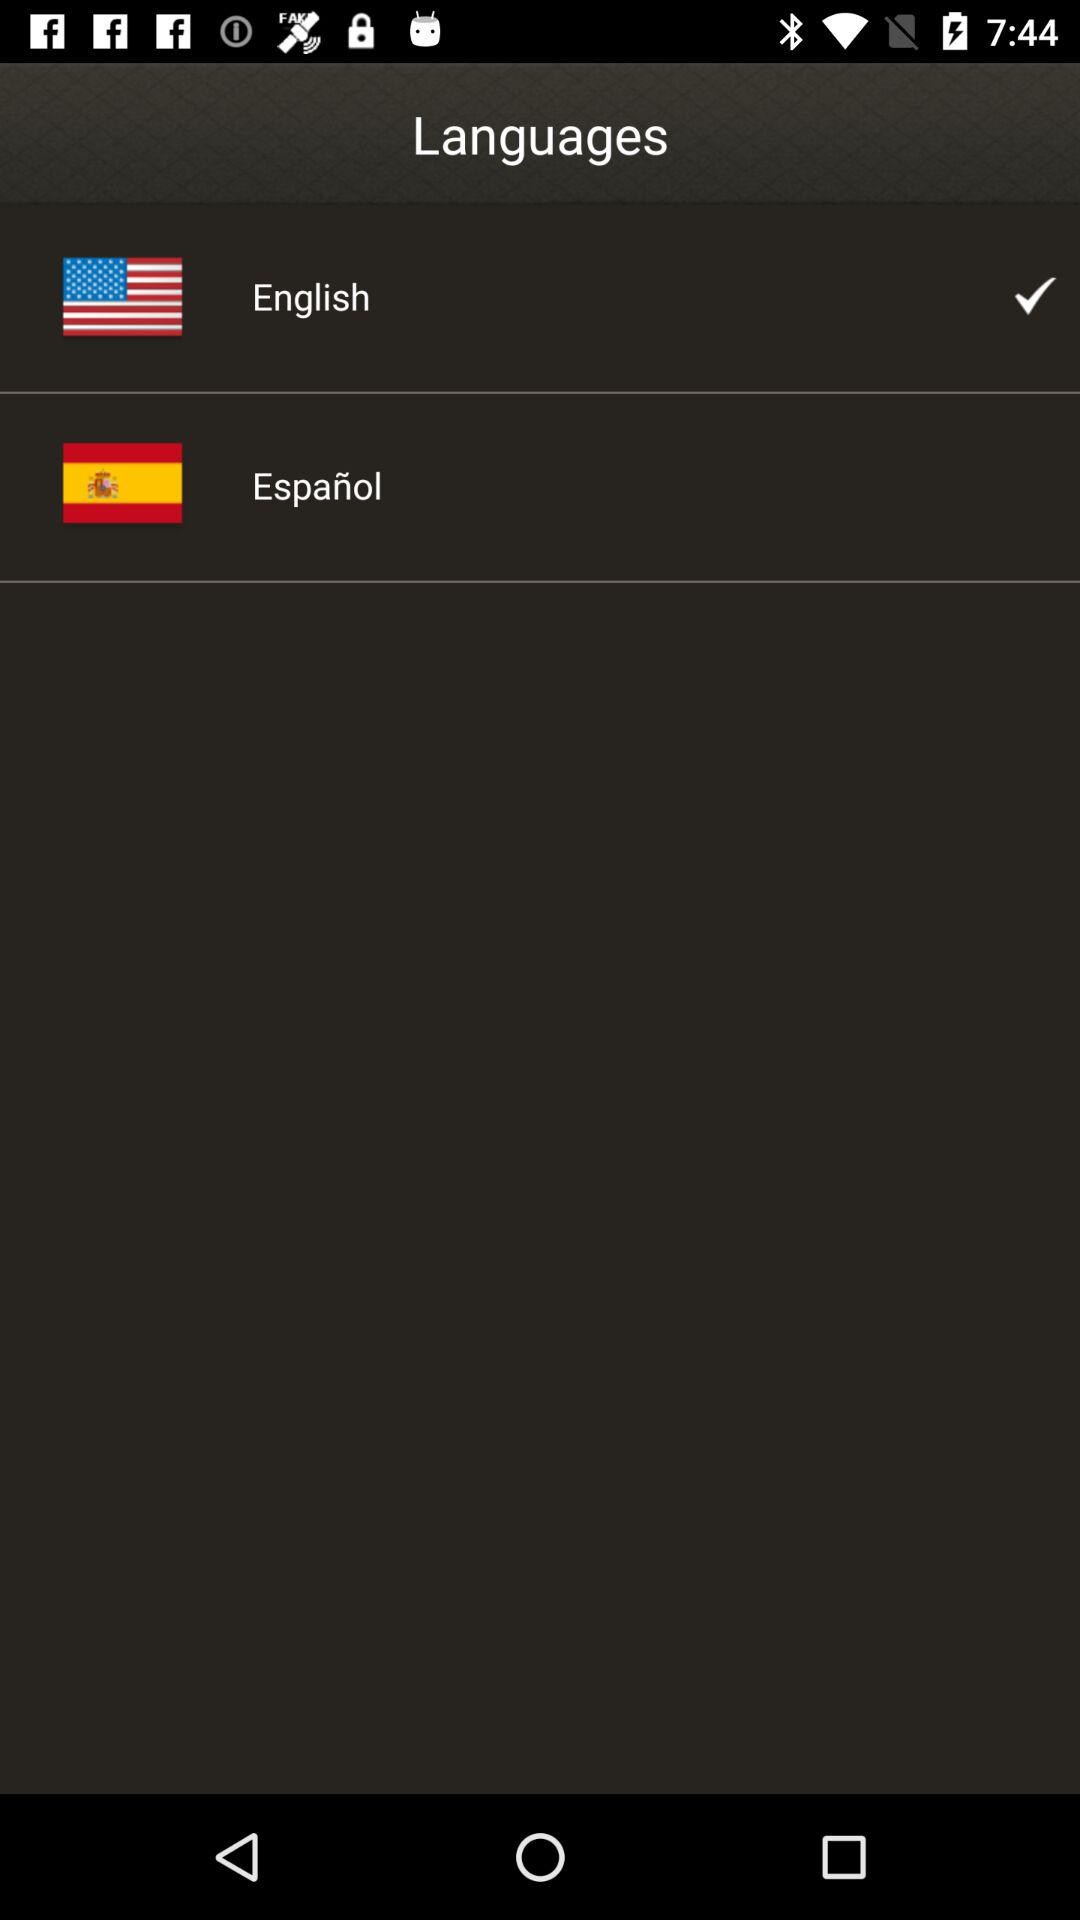How many languages are available?
Answer the question using a single word or phrase. 2 